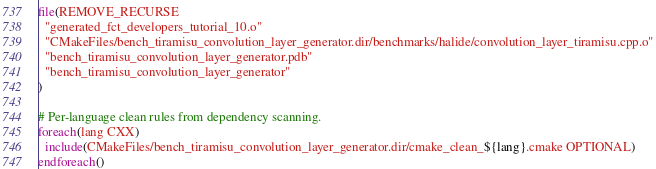Convert code to text. <code><loc_0><loc_0><loc_500><loc_500><_CMake_>file(REMOVE_RECURSE
  "generated_fct_developers_tutorial_10.o"
  "CMakeFiles/bench_tiramisu_convolution_layer_generator.dir/benchmarks/halide/convolution_layer_tiramisu.cpp.o"
  "bench_tiramisu_convolution_layer_generator.pdb"
  "bench_tiramisu_convolution_layer_generator"
)

# Per-language clean rules from dependency scanning.
foreach(lang CXX)
  include(CMakeFiles/bench_tiramisu_convolution_layer_generator.dir/cmake_clean_${lang}.cmake OPTIONAL)
endforeach()
</code> 